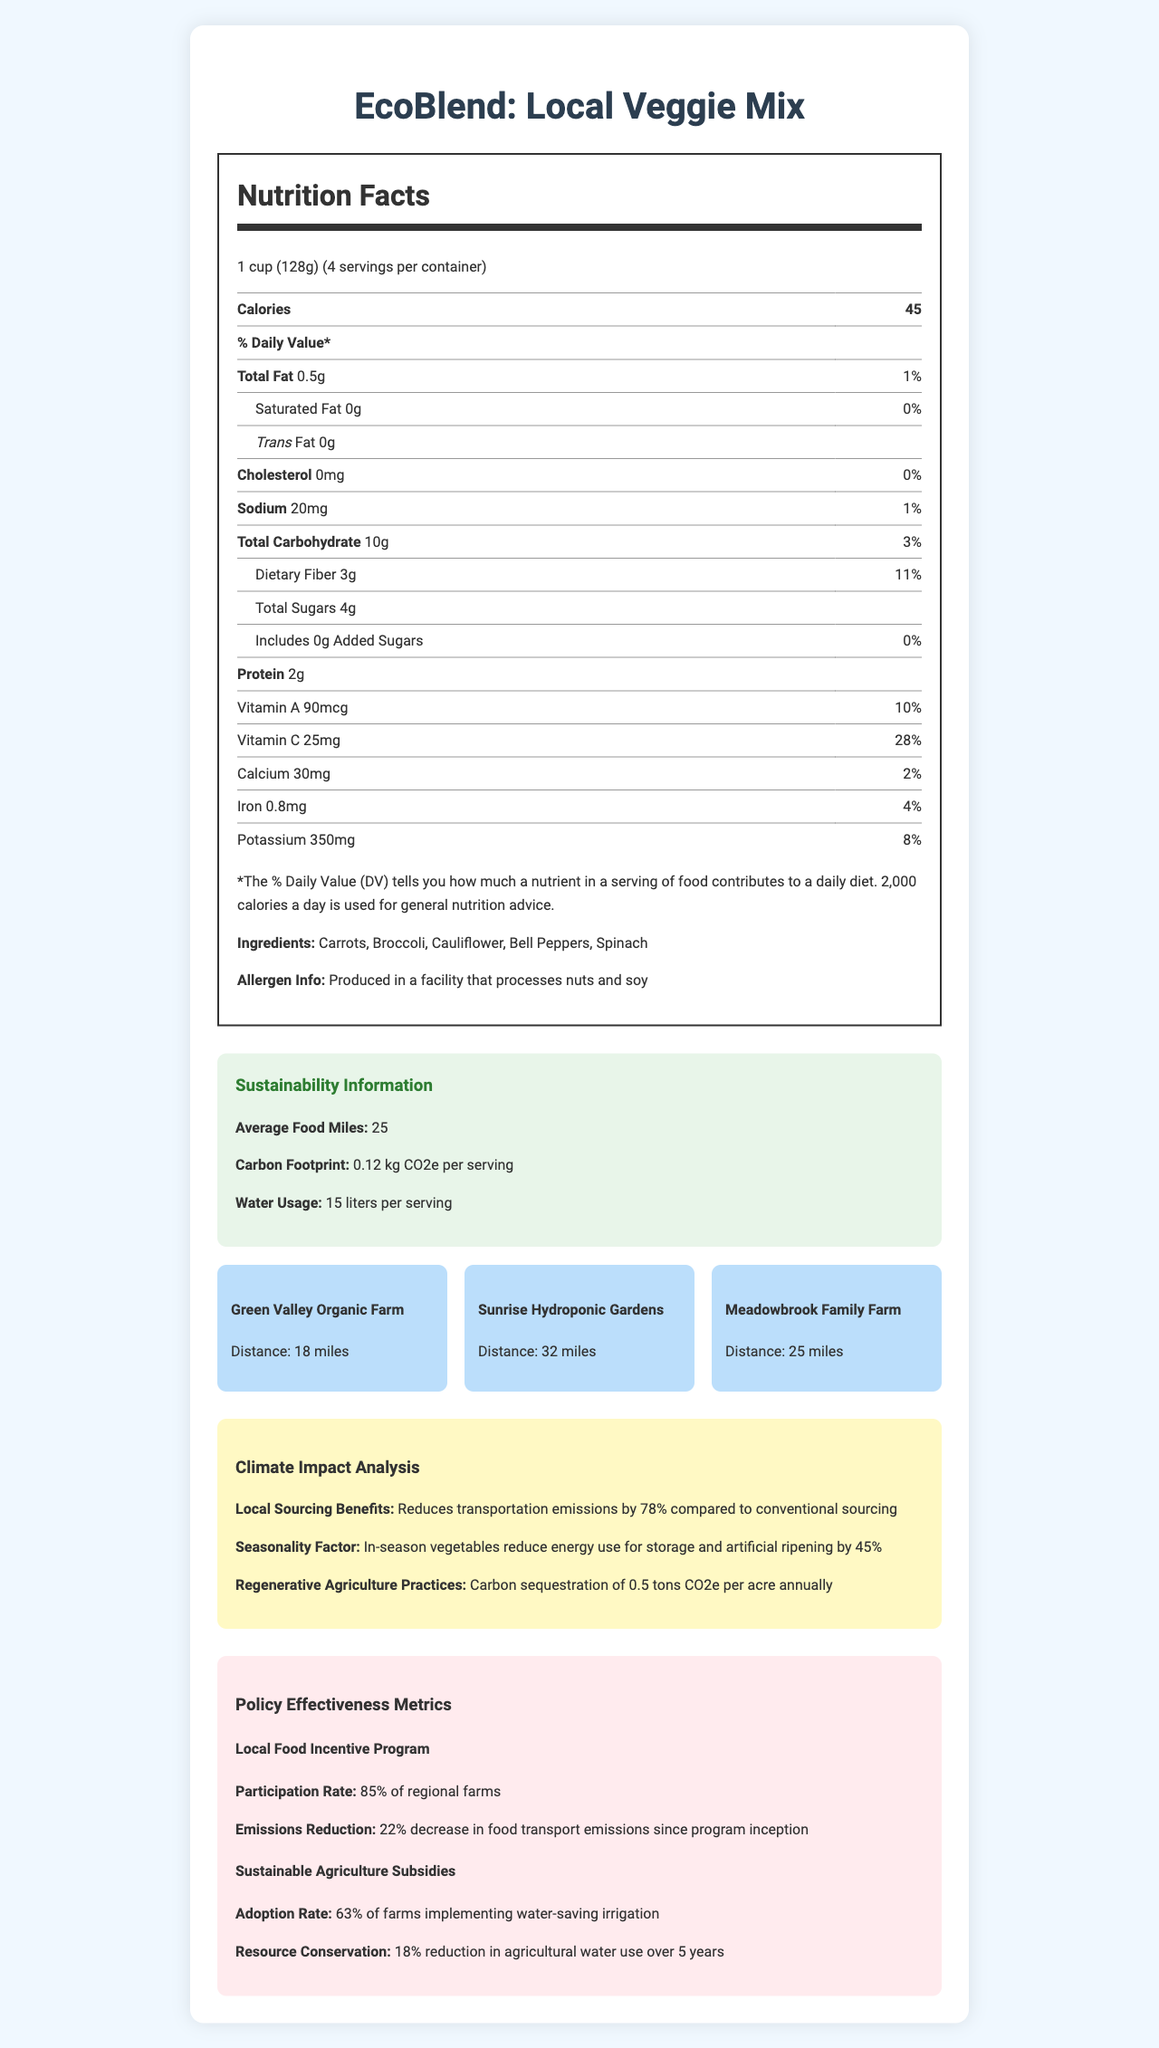what is the serving size for EcoBlend: Local Veggie Mix? The serving size is directly stated at the top of the Nutrition Facts section as "1 cup (128g)".
Answer: 1 cup (128g) how many servings are there per container? The number of servings per container is indicated underneath the serving size in the Nutrition Facts section.
Answer: 4 how many calories are in each serving? The calories per serving are listed prominently at the top of the Nutrition Facts section as "Calories 45".
Answer: 45 what is the daily value of dietary fiber in a serving? The daily value percentage for dietary fiber is provided next to its amount, which is "3g", followed by "11%".
Answer: 11% what are the main ingredients of the EcoBlend: Local Veggie Mix? The main ingredients are listed at the bottom of the Nutrition Facts section.
Answer: Carrots, Broccoli, Cauliflower, Bell Peppers, Spinach where is the source location with the longest distance to the point of sale? The distance from Sunrise Hydroponic Gardens is listed as "32 miles", which is the longest distance compared to the other source locations.
Answer: Sunrise Hydroponic Gardens which vitamin has the highest daily value percentage per serving? A. Vitamin A B. Vitamin C C. Calcium D. Iron Vitamin C has a daily value percentage of 28%, which is higher than that of Vitamin A (10%), Calcium (2%), and Iron (4%).
Answer: B how much sodium is in a serving? A. 10mg B. 15mg C. 20mg D. 25mg The sodium content is listed as "20mg" next to the daily value of 1%.
Answer: C is the EcoBlend: Local Veggie Mix produced in a facility that processes nuts? At the bottom of the Nutrition Facts section, it is noted: "Produced in a facility that processes nuts and soy".
Answer: Yes what is the carbon footprint of a serving of the EcoBlend: Local Veggie Mix? The carbon footprint is listed under the Sustainability Information section as "0.12 kg CO2e per serving".
Answer: 0.12 kg CO2e per serving describe the key points of the EcoBlend: Local Veggie Mix Nutrition Facts document. The document provides comprehensive information on the nutritional content, ingredients, allergen information, sustainability efforts, source locations, climate impact analysis, and policy metrics for EcoBlend: Local Veggie Mix.
Answer: The document details the nutrition facts for "EcoBlend: Local Veggie Mix", including serving size, calories, macronutrients, vitamins, and minerals. Ingredients and allergen information are provided. Sustainability information such as average food miles, carbon footprint, and water usage per serving are included. Source locations for the ingredients, climate impact analysis, and policy effectiveness metrics related to local food incentives and sustainable agriculture subsidies are also featured. how much water is used per serving of the EcoBlend: Local Veggie Mix? The water usage per serving is listed under the Sustainability Information section as "15 liters per serving".
Answer: 15 liters per serving what type of farms are implementing water-saving irrigation practices according to the document? The policy effectiveness metrics state that "63% of farms" are implementing water-saving irrigation.
Answer: 63% of farms which farm is located the closest to the point of sale? The distance from Green Valley Organic Farm is listed as "18 miles", the shortest distance among the source locations.
Answer: Green Valley Organic Farm how does in-season local vegetable sourcing affect energy use for storage and artificial ripening? Under the Climate Impact Analysis section, it is stated: "In-season vegetables reduce energy use for storage and artificial ripening by 45%".
Answer: Reduces energy use by 45% how many grams of added sugars are in each serving? The amount of added sugars per serving is listed as "0g" next to the corresponding daily value of 0%.
Answer: 0g what health-related nutrient does not have any amount or daily value percentage listed? The Trans Fat amount is listed as "0g" without any related daily value percentage in the Nutrition Facts section.
Answer: Trans Fat what percentage of regional farms participate in the Local Food Incentive Program? Under the Policy Effectiveness Metrics section, it is stated that the participation rate in the Local Food Incentive Program is "85% of regional farms".
Answer: 85% how many grams of protein are in each serving of the EcoBlend: Local Veggie Mix? The protein content is listed as "2g" per serving in the Nutrition Facts section.
Answer: 2g 